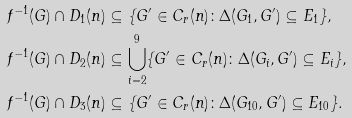<formula> <loc_0><loc_0><loc_500><loc_500>f ^ { - 1 } ( G ) \cap D _ { 1 } ( n ) & \subseteq \{ G ^ { \prime } \in C _ { r } ( n ) \colon \Delta ( G _ { 1 } , G ^ { \prime } ) \subseteq E _ { 1 } \} , \\ f ^ { - 1 } ( G ) \cap D _ { 2 } ( n ) & \subseteq \bigcup _ { i = 2 } ^ { 9 } \{ G ^ { \prime } \in C _ { r } ( n ) \colon \Delta ( G _ { i } , G ^ { \prime } ) \subseteq E _ { i } \} , \\ f ^ { - 1 } ( G ) \cap D _ { 3 } ( n ) & \subseteq \{ G ^ { \prime } \in C _ { r } ( n ) \colon \Delta ( G _ { 1 0 } , G ^ { \prime } ) \subseteq E _ { 1 0 } \} .</formula> 